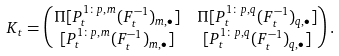<formula> <loc_0><loc_0><loc_500><loc_500>K _ { t } & = \begin{pmatrix} \Pi [ P _ { t } ^ { 1 \colon p , m } ( F _ { t } ^ { - 1 } ) _ { m , \bullet } ] & \Pi [ P _ { t } ^ { 1 \colon p , q } ( F _ { t } ^ { - 1 } ) _ { q , \bullet } ] \\ [ P _ { t } ^ { 1 \colon p , m } ( F _ { t } ^ { - 1 } ) _ { m , \bullet } ] & [ P _ { t } ^ { 1 \colon p , q } ( F _ { t } ^ { - 1 } ) _ { q , \bullet } ] \end{pmatrix} .</formula> 